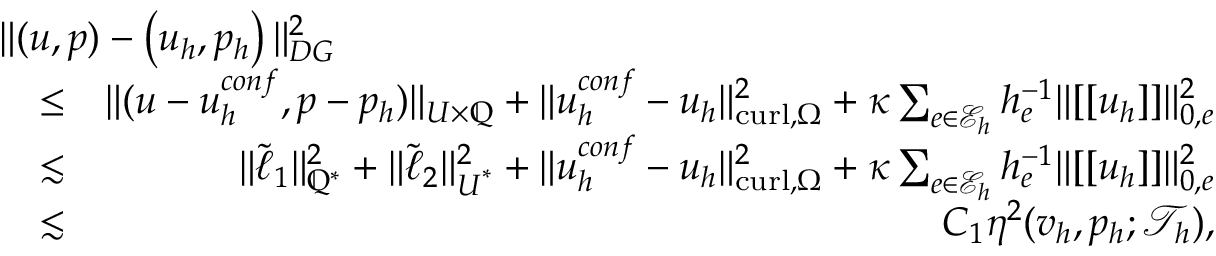<formula> <loc_0><loc_0><loc_500><loc_500>\begin{array} { r l r } { { \| ( u , { p } ) - \left ( u _ { h } , { p } _ { h } \right ) \| _ { D G } ^ { 2 } } } \\ & { \leq } & { \| ( u - u _ { h } ^ { c o n f } , { p } - { p } _ { h } ) \| _ { U \times \mathbb { Q } } + \| u _ { h } ^ { c o n f } - u _ { h } \| _ { c u r l , \Omega } ^ { 2 } + \kappa \sum _ { e \in \mathcal { E } _ { h } } h _ { e } ^ { - 1 } \| [ [ u _ { h } ] ] \| _ { 0 , e } ^ { 2 } } \\ & { \lesssim } & { \| \tilde { \ell } _ { 1 } \| _ { \mathbb { Q } ^ { * } } ^ { 2 } + \| \tilde { \ell } _ { 2 } \| _ { U ^ { * } } ^ { 2 } + \| u _ { h } ^ { c o n f } - u _ { h } \| _ { c u r l , \Omega } ^ { 2 } + \kappa \sum _ { e \in \mathcal { E } _ { h } } h _ { e } ^ { - 1 } \| [ [ u _ { h } ] ] \| _ { 0 , e } ^ { 2 } } \\ & { \lesssim } & { C _ { 1 } \eta ^ { 2 } ( v _ { h } , p _ { h } ; \mathcal { T } _ { h } ) , } \end{array}</formula> 